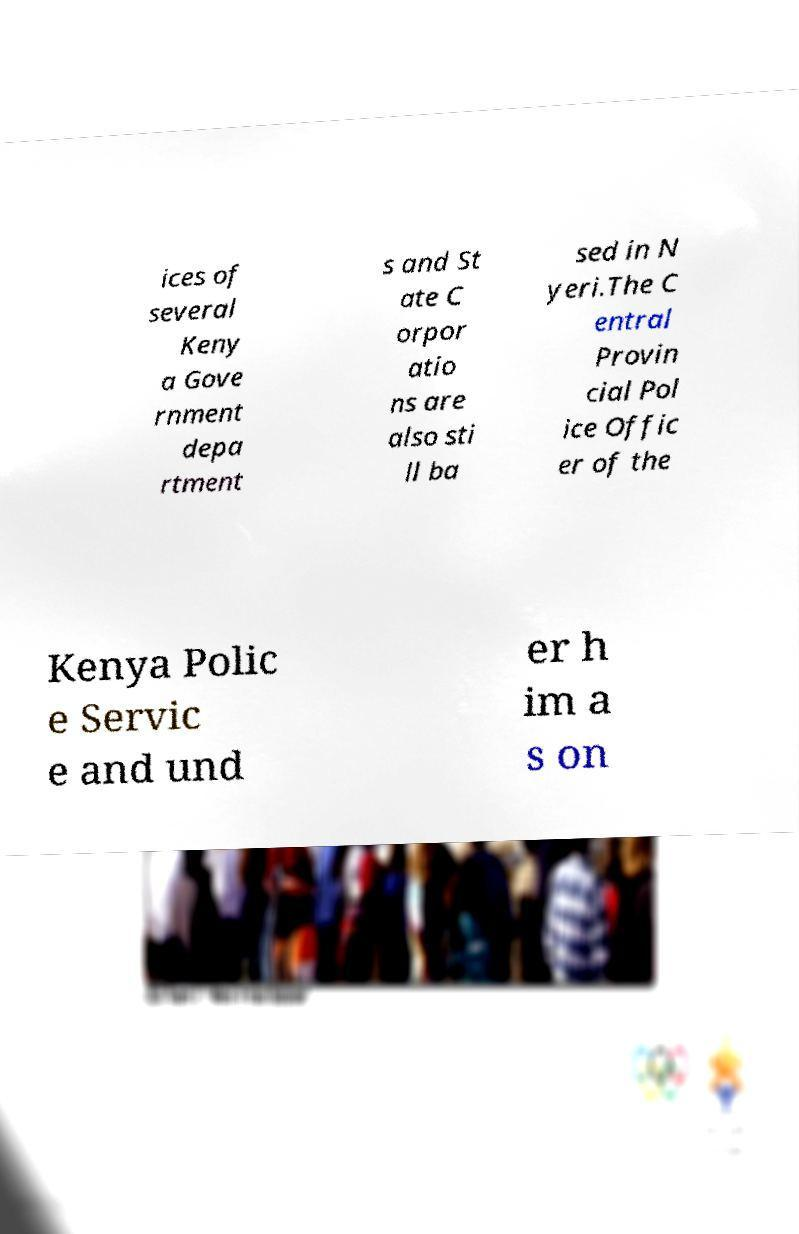Can you accurately transcribe the text from the provided image for me? ices of several Keny a Gove rnment depa rtment s and St ate C orpor atio ns are also sti ll ba sed in N yeri.The C entral Provin cial Pol ice Offic er of the Kenya Polic e Servic e and und er h im a s on 